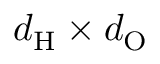Convert formula to latex. <formula><loc_0><loc_0><loc_500><loc_500>d _ { H } \times d _ { O }</formula> 